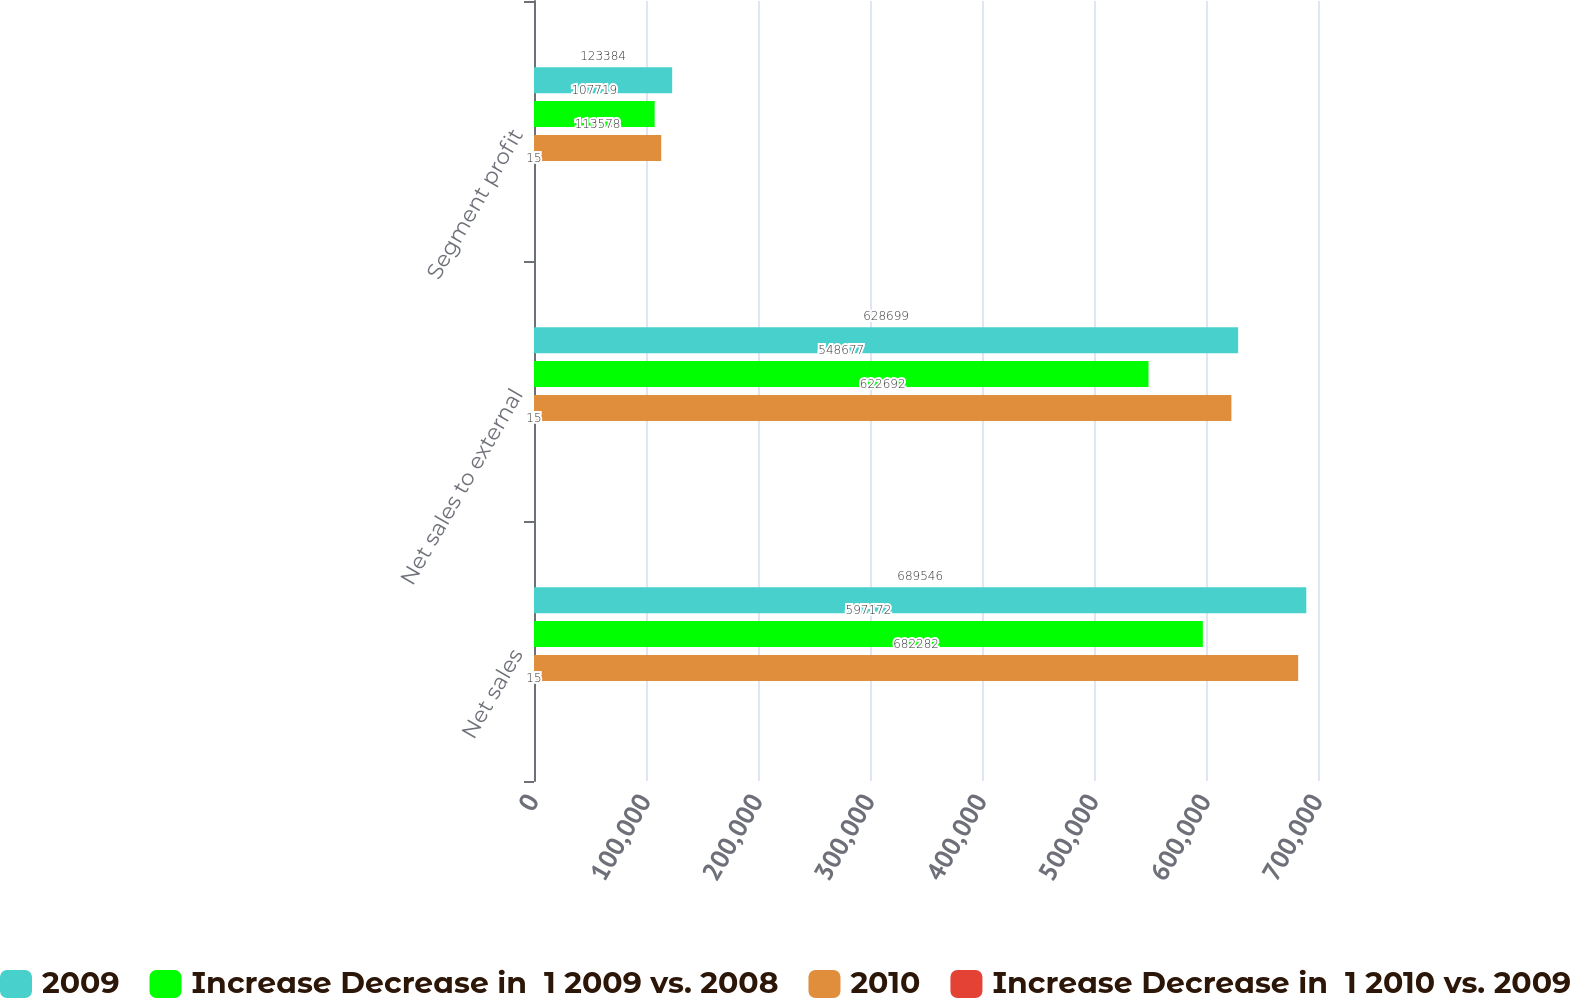Convert chart to OTSL. <chart><loc_0><loc_0><loc_500><loc_500><stacked_bar_chart><ecel><fcel>Net sales<fcel>Net sales to external<fcel>Segment profit<nl><fcel>2009<fcel>689546<fcel>628699<fcel>123384<nl><fcel>Increase Decrease in  1 2009 vs. 2008<fcel>597172<fcel>548677<fcel>107719<nl><fcel>2010<fcel>682282<fcel>622692<fcel>113578<nl><fcel>Increase Decrease in  1 2010 vs. 2009<fcel>15<fcel>15<fcel>15<nl></chart> 